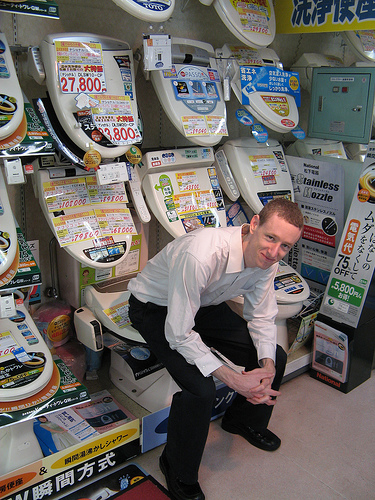What might be the theme or purpose of this image? The theme of this image seems to be a humorous take on a bathroom fixture store, possibly aimed at making the shopping experience more entertaining and memorable. Can you tell what sets these toilets apart from typical ones? Many of the toilets featured include advanced features such as electronic bidet functions, heated seats, and eco-friendly water usage, which set them apart from more typical models. 